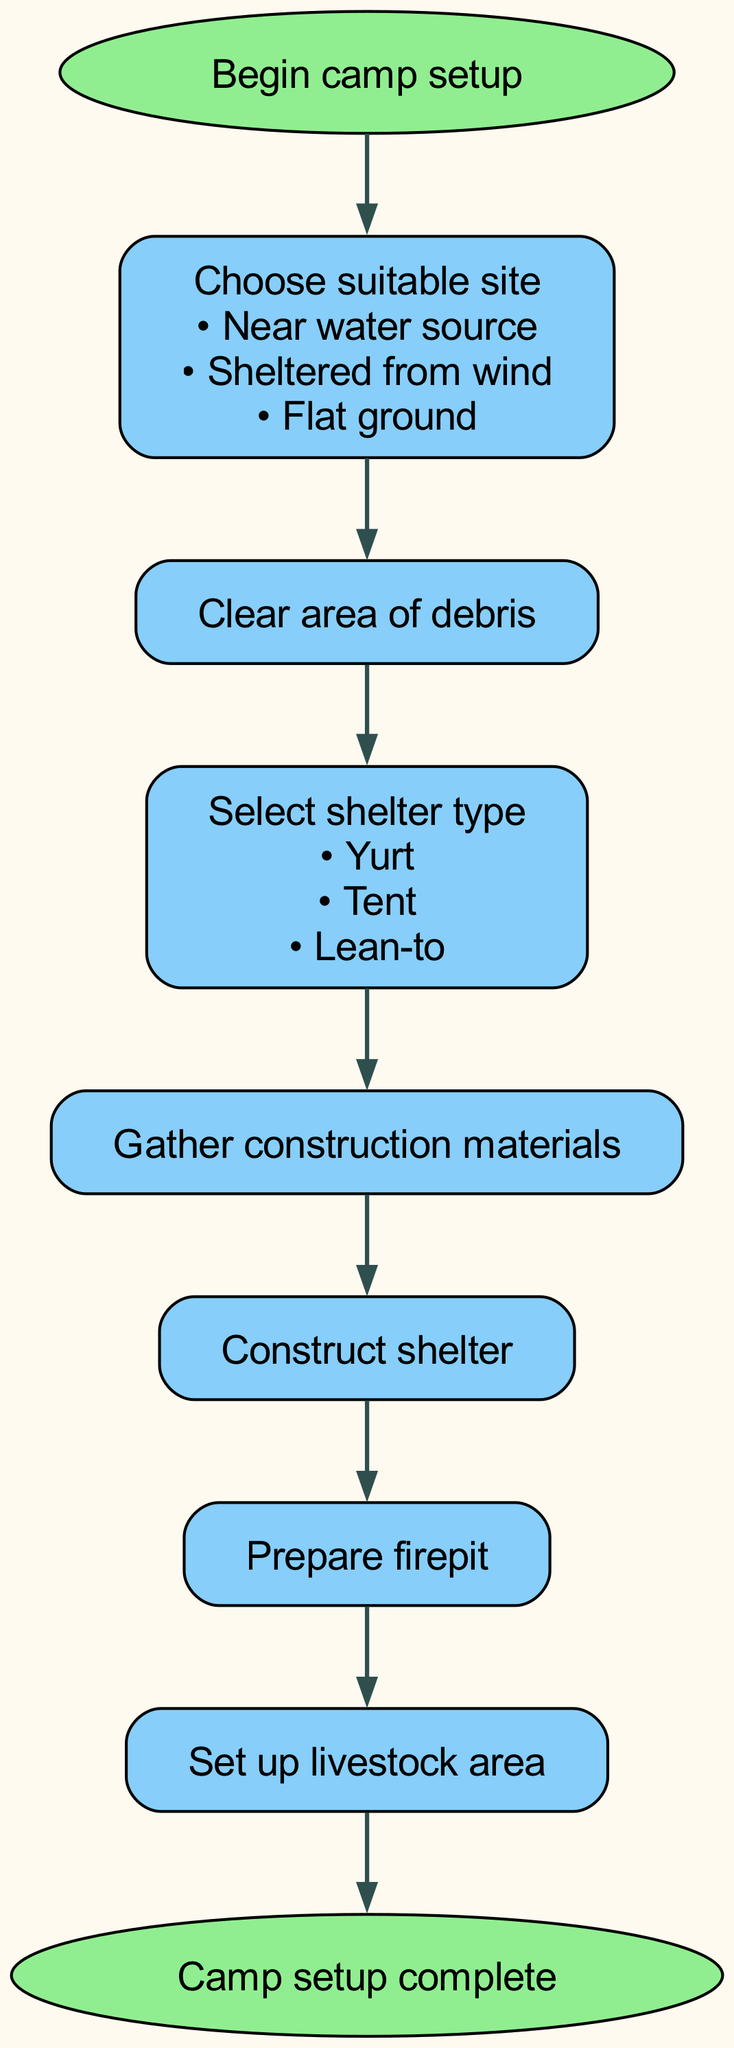What is the first step in camp setup? The diagram starts with the node labeled "Begin camp setup," indicating it is the first step.
Answer: Begin camp setup How many criteria are listed for site selection? The node for "Choose suitable site" includes three criteria: near water source, sheltered from wind, and flat ground. Therefore, there are three criteria.
Answer: 3 What are the three types of shelter that can be selected? The node labeled "Select shelter type" has the options listed as Yurt, Tent, and Lean-to. These are the three types of shelters.
Answer: Yurt, Tent, Lean-to Which step comes after clearing the area? Following the "Clear area of debris" step, the next step according to the diagram is "Select shelter type."
Answer: Select shelter type What is the last step before completing the camp setup? Before reaching "Camp setup complete," the final step shown in the flow chart is "Set up livestock area."
Answer: Set up livestock area How does the process flow from building the shelter to preparing the firepit? After "Construct shelter," the sequence leads directly to the "Prepare firepit," indicating a direct relationship in the flow of tasks.
Answer: Prepared firepit What action is taken after the shelter type is selected? The flow chart indicates that after selecting the shelter type, the next step is to "Gather construction materials."
Answer: Gather construction materials How many nodes are there in total in this flow chart? The diagram includes a total of eight nodes, which include all steps involved in the camp setup process.
Answer: 8 What is required before setting up an area for livestock? Before setting up the livestock area, one must go through the "Prepare firepit" step, which creates a sequence of actions leading to the livestock setup.
Answer: Prepare firepit 